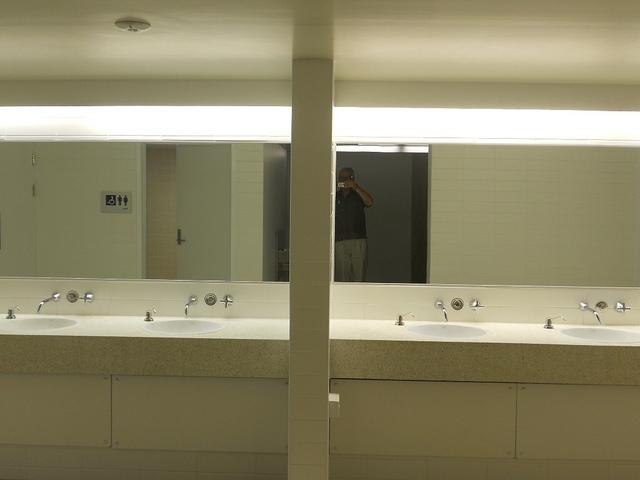What bathroom is it on the right? men 